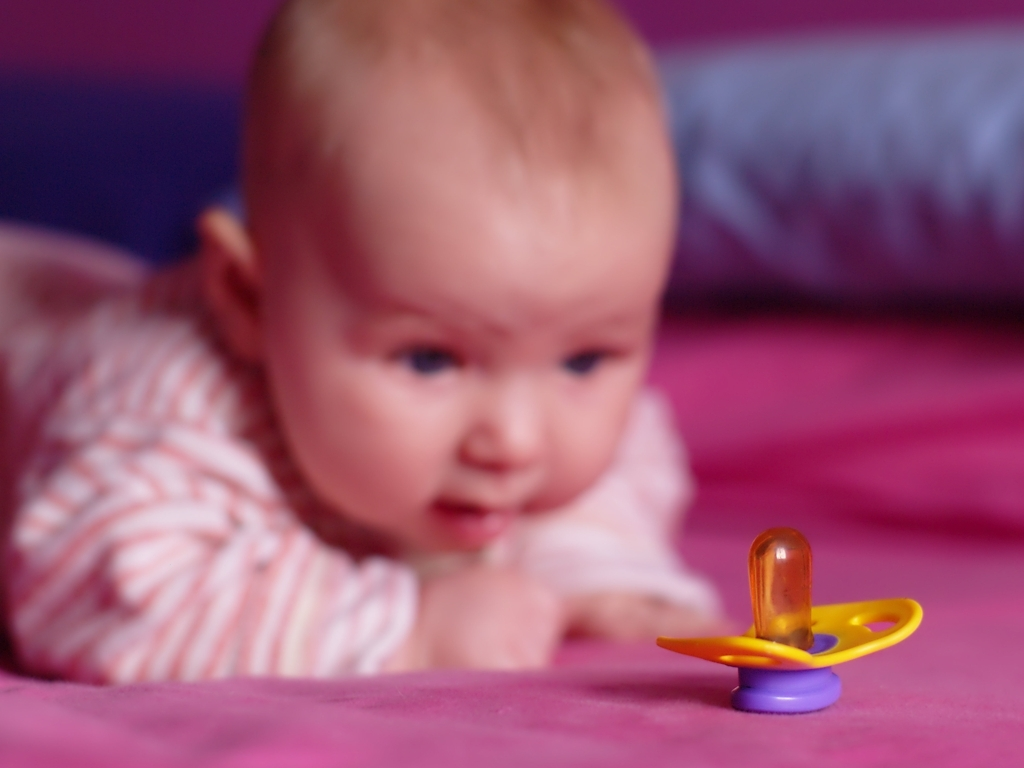What emotions might the infant be experiencing? Based on the infant's body language and facial expression, with the slightly furrowed brow and the open mouth that may indicate the beginnings of a cry or fuss, it's possible that the infant is experiencing discomfort or frustration. This could be due to the pacifier being out of reach, creating a sense of need or want. However, it's important to note that interpreting an infant's emotions through an image without context can be challenging. 